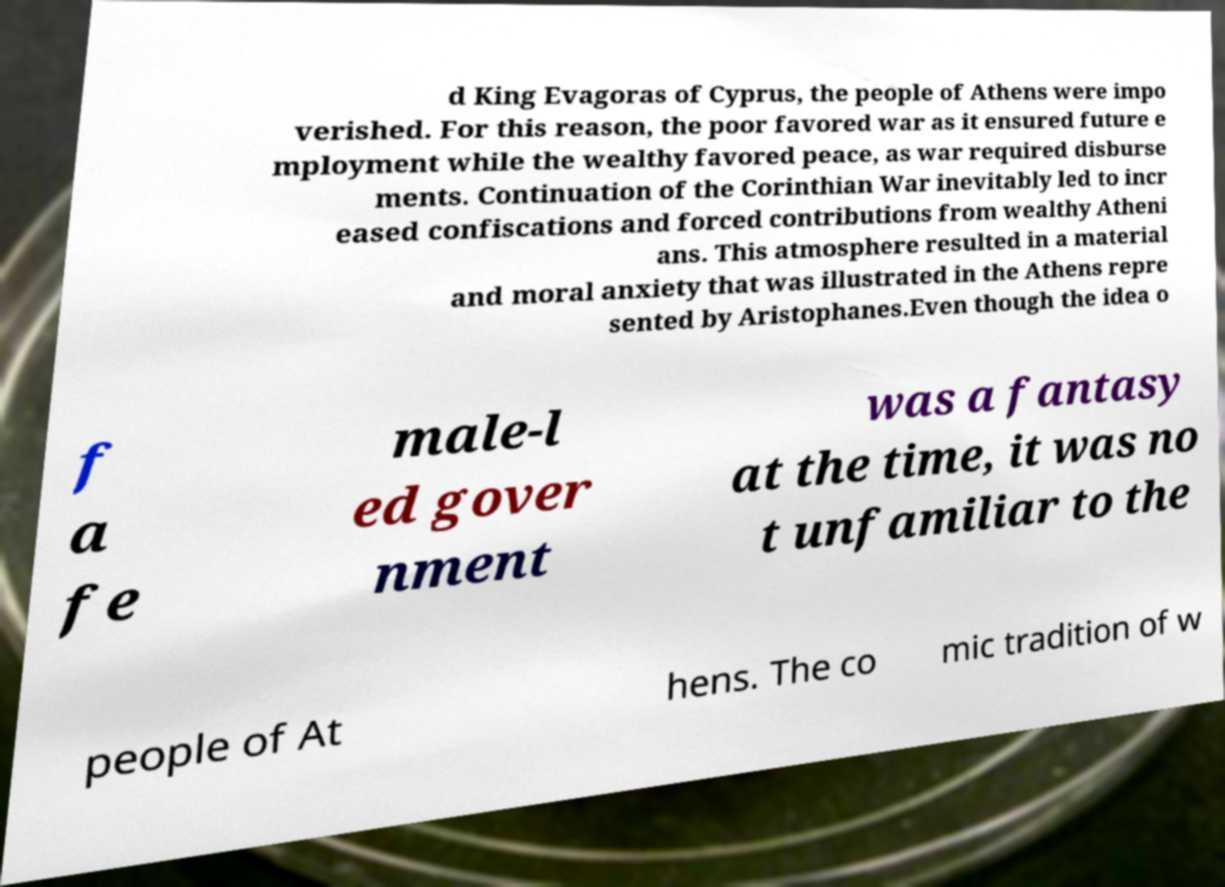I need the written content from this picture converted into text. Can you do that? d King Evagoras of Cyprus, the people of Athens were impo verished. For this reason, the poor favored war as it ensured future e mployment while the wealthy favored peace, as war required disburse ments. Continuation of the Corinthian War inevitably led to incr eased confiscations and forced contributions from wealthy Atheni ans. This atmosphere resulted in a material and moral anxiety that was illustrated in the Athens repre sented by Aristophanes.Even though the idea o f a fe male-l ed gover nment was a fantasy at the time, it was no t unfamiliar to the people of At hens. The co mic tradition of w 